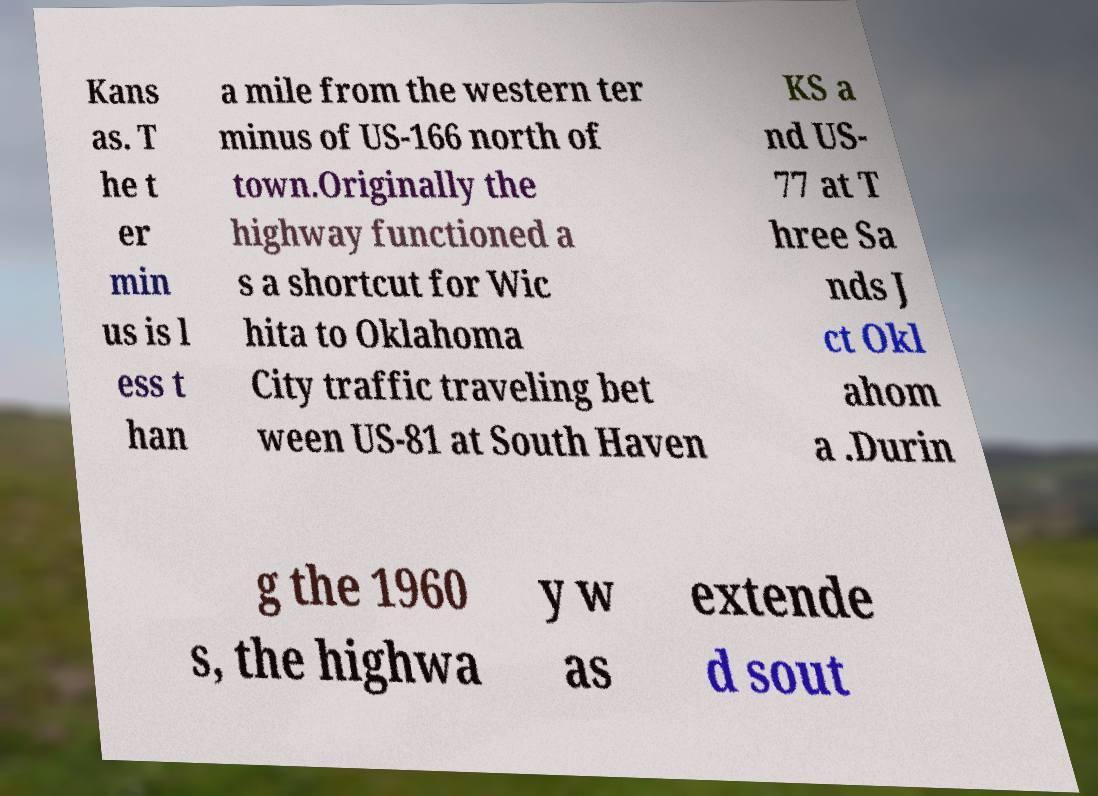Can you read and provide the text displayed in the image?This photo seems to have some interesting text. Can you extract and type it out for me? Kans as. T he t er min us is l ess t han a mile from the western ter minus of US-166 north of town.Originally the highway functioned a s a shortcut for Wic hita to Oklahoma City traffic traveling bet ween US-81 at South Haven KS a nd US- 77 at T hree Sa nds J ct Okl ahom a .Durin g the 1960 s, the highwa y w as extende d sout 